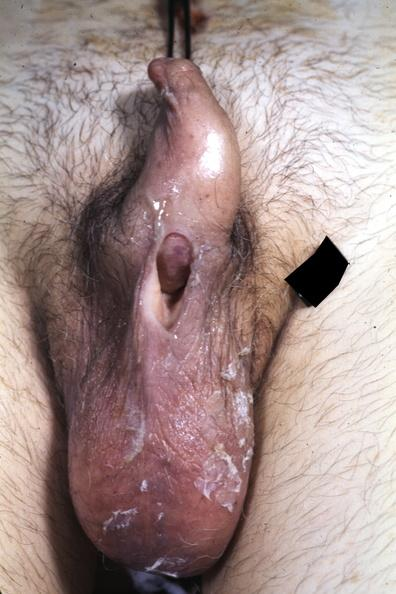what is present?
Answer the question using a single word or phrase. Penis 